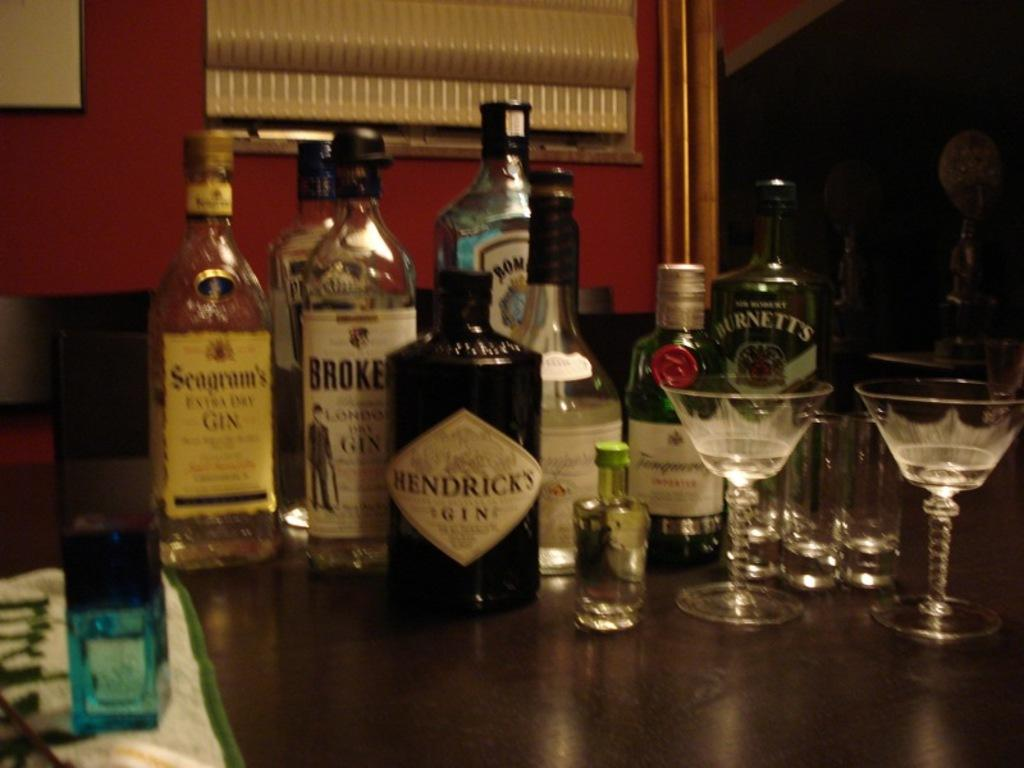What type of bottles are in the image? There are wine bottles with sticker labels in the image. What feature do the wine bottles have? The wine bottles have lids. What can be seen on the table in the image? There are glasses on the table. How would you describe the lighting in the image? The background of the image is dark. What type of attack is being planned in the image? There is no indication of an attack or any planning in the image; it features wine bottles, lids, glasses, and a dark background. Can you tell me where the drawer is located in the image? There is no drawer present in the image. 